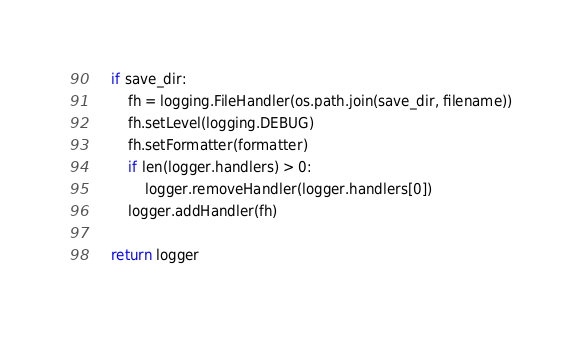Convert code to text. <code><loc_0><loc_0><loc_500><loc_500><_Python_>    if save_dir:
        fh = logging.FileHandler(os.path.join(save_dir, filename))
        fh.setLevel(logging.DEBUG)
        fh.setFormatter(formatter)
        if len(logger.handlers) > 0:
            logger.removeHandler(logger.handlers[0])
        logger.addHandler(fh)

    return logger

</code> 